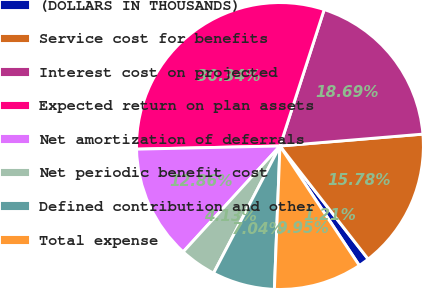Convert chart to OTSL. <chart><loc_0><loc_0><loc_500><loc_500><pie_chart><fcel>(DOLLARS IN THOUSANDS)<fcel>Service cost for benefits<fcel>Interest cost on projected<fcel>Expected return on plan assets<fcel>Net amortization of deferrals<fcel>Net periodic benefit cost<fcel>Defined contribution and other<fcel>Total expense<nl><fcel>1.21%<fcel>15.78%<fcel>18.69%<fcel>30.34%<fcel>12.86%<fcel>4.13%<fcel>7.04%<fcel>9.95%<nl></chart> 